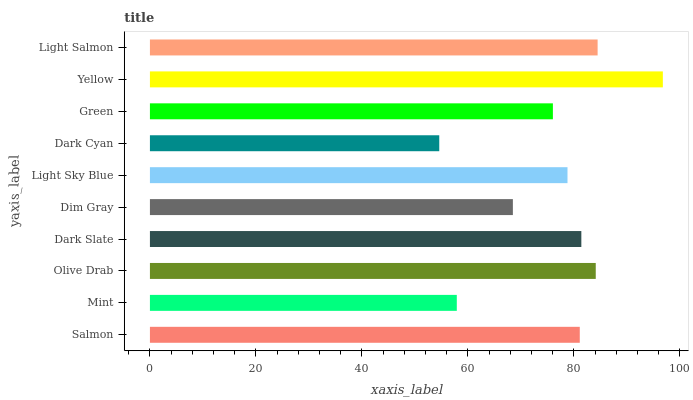Is Dark Cyan the minimum?
Answer yes or no. Yes. Is Yellow the maximum?
Answer yes or no. Yes. Is Mint the minimum?
Answer yes or no. No. Is Mint the maximum?
Answer yes or no. No. Is Salmon greater than Mint?
Answer yes or no. Yes. Is Mint less than Salmon?
Answer yes or no. Yes. Is Mint greater than Salmon?
Answer yes or no. No. Is Salmon less than Mint?
Answer yes or no. No. Is Salmon the high median?
Answer yes or no. Yes. Is Light Sky Blue the low median?
Answer yes or no. Yes. Is Dim Gray the high median?
Answer yes or no. No. Is Olive Drab the low median?
Answer yes or no. No. 